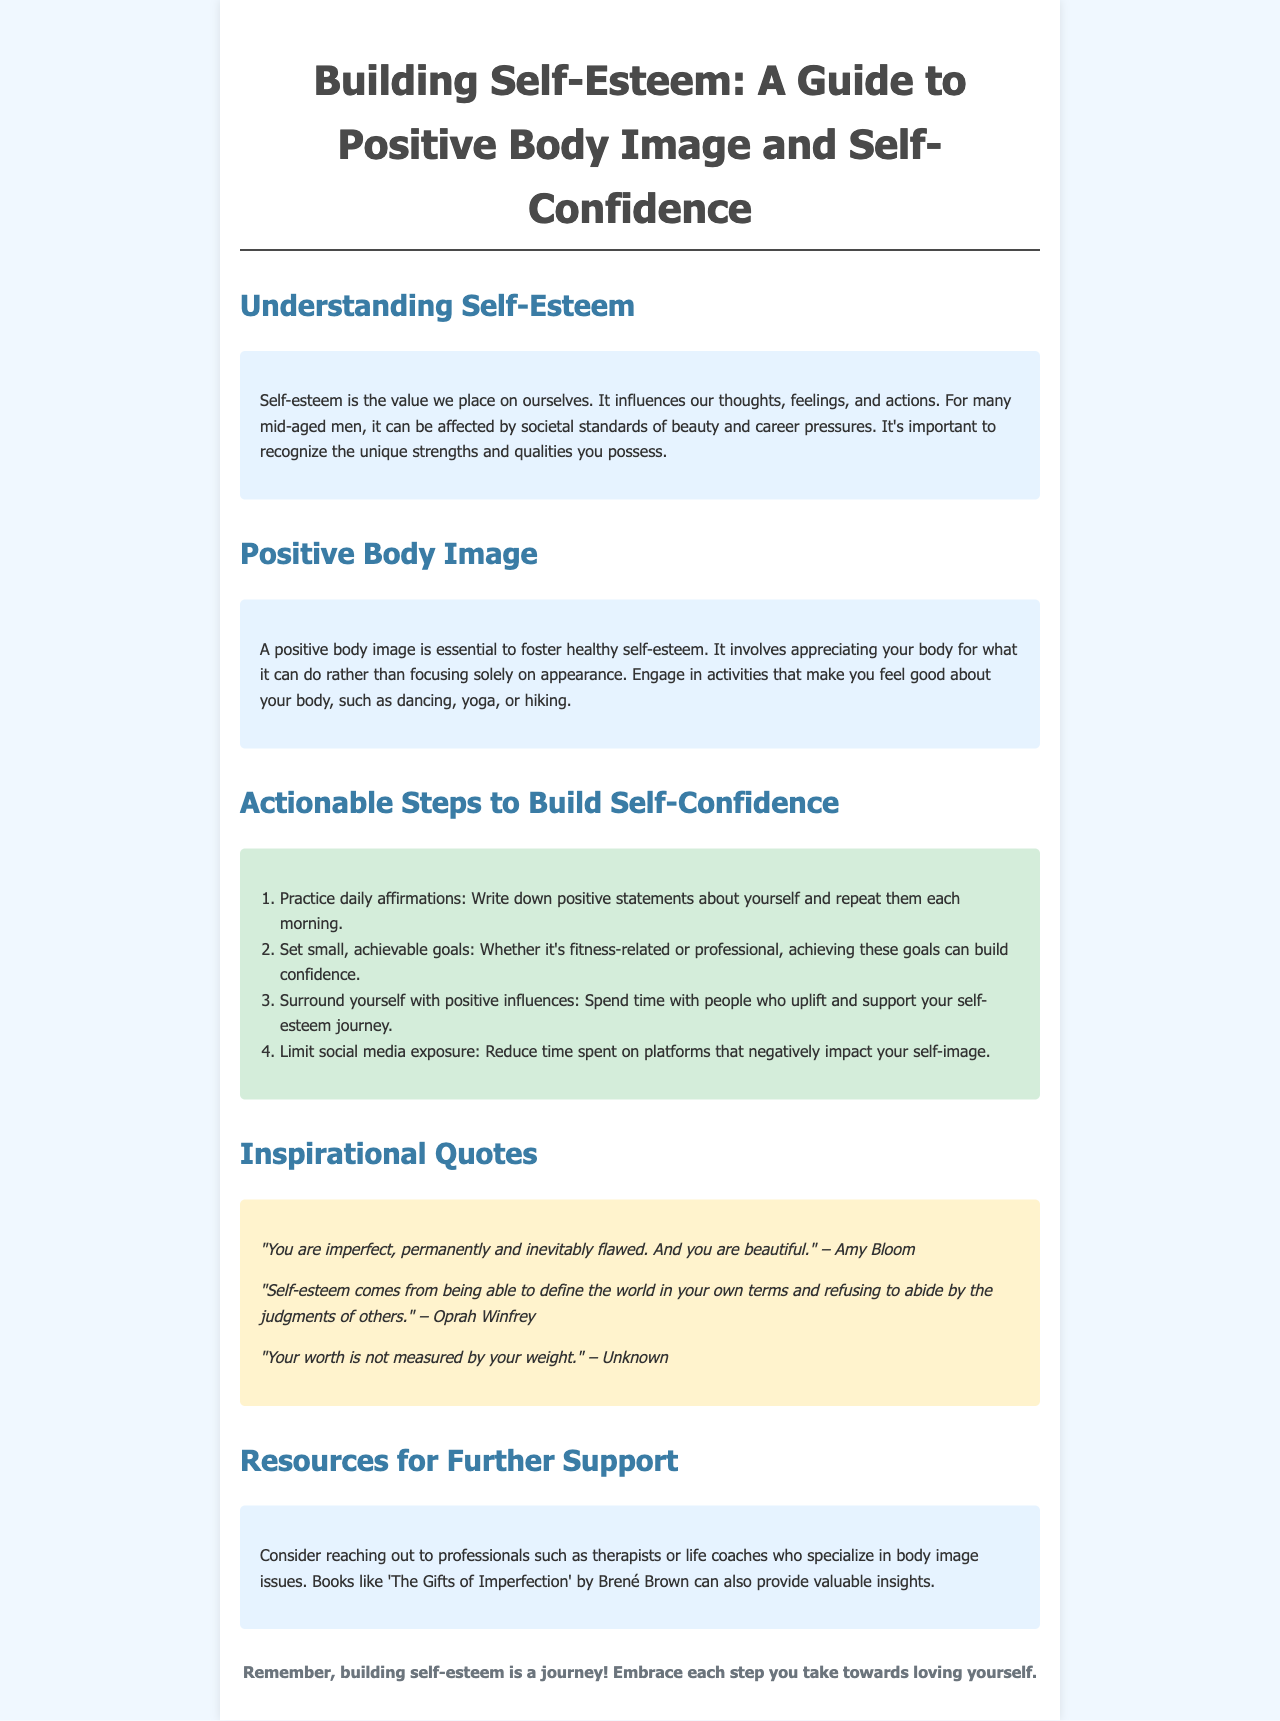What is the title of the document? The title is clearly stated at the top of the brochure, introducing the main topic covered.
Answer: Building Self-Esteem: A Guide to Positive Body Image and Self-Confidence What is one of the actionable steps listed to build self-confidence? The document lists specific steps to enhance self-confidence, and this is one of them.
Answer: Practice daily affirmations Who is quoted as saying "You are imperfect, permanently and inevitably flawed. And you are beautiful"? The author of the quote is mentioned within the quotes section of the document.
Answer: Amy Bloom What color is used for the background of the content section? This refers to the background color mentioned in the styling of the document.
Answer: Light blue What is emphasized as essential for a positive body image? The content specifically mentions an important factor needed for a positive body image.
Answer: Appreciating your body for what it can do How many actionable steps are provided in the document? A count of the steps listed in the actionable section reveals the total number provided.
Answer: Four What type of professionals are suggested for further support? This asks about the specific type of experts mentioned in the resources section.
Answer: Therapists What is the overarching theme of the brochure? The main focus of the brochure as concluded from the content and layout is reflected here.
Answer: Building self-esteem 